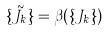Convert formula to latex. <formula><loc_0><loc_0><loc_500><loc_500>\{ \tilde { J } _ { k } \} = \beta ( \{ J _ { k } \} )</formula> 